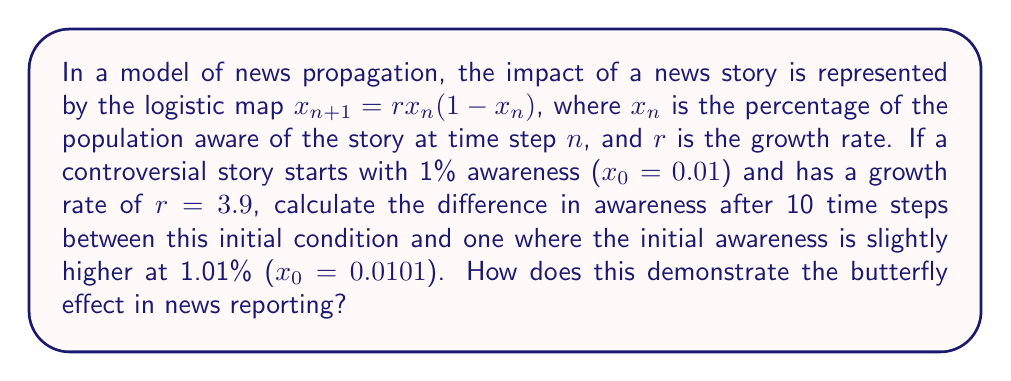Could you help me with this problem? To solve this problem, we need to iterate the logistic map for both initial conditions and compare the results after 10 steps. Let's break it down:

1. For $x_0 = 0.01$:
   $x_1 = 3.9 * 0.01 * (1 - 0.01) = 0.03861$
   $x_2 = 3.9 * 0.03861 * (1 - 0.03861) = 0.14511$
   ...
   (continue until $x_{10}$)

2. For $x_0 = 0.0101$:
   $x_1 = 3.9 * 0.0101 * (1 - 0.0101) = 0.03899$
   $x_2 = 3.9 * 0.03899 * (1 - 0.03899) = 0.14645$
   ...
   (continue until $x_{10}$)

3. After 10 iterations:
   For $x_0 = 0.01$: $x_{10} \approx 0.8679$
   For $x_0 = 0.0101$: $x_{10} \approx 0.7476$

4. Calculate the difference:
   $|0.8679 - 0.7476| \approx 0.1203$ or 12.03%

This significant difference in awareness (12.03%) after just 10 time steps, resulting from a tiny initial difference of 0.01%, demonstrates the butterfly effect in news reporting. It shows how small changes in initial conditions can lead to vastly different outcomes over time, highlighting the sensitivity and unpredictability of public perception in response to news stories.
Answer: 12.03% 